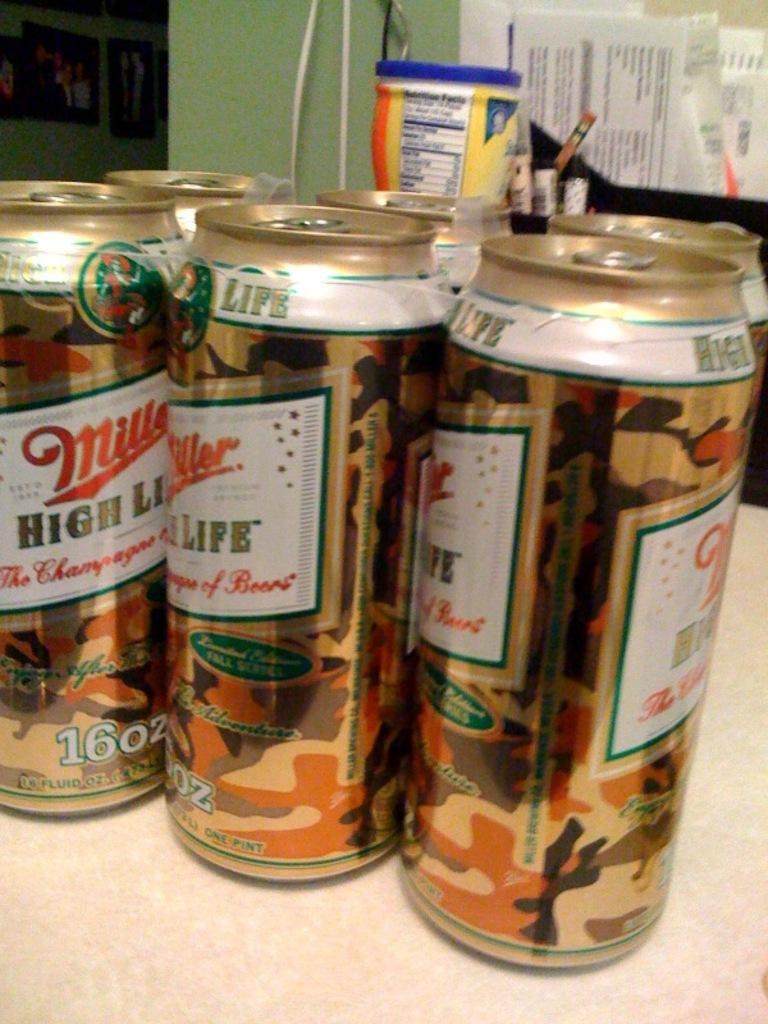<image>
Offer a succinct explanation of the picture presented. Camouflage cans of Miller High Life sit on a table together. 